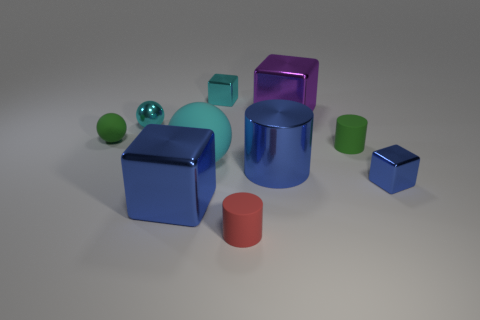Subtract all blue blocks. How many were subtracted if there are1blue blocks left? 1 Subtract all cubes. How many objects are left? 6 Add 2 tiny shiny balls. How many tiny shiny balls are left? 3 Add 4 small brown matte cubes. How many small brown matte cubes exist? 4 Subtract 1 blue cylinders. How many objects are left? 9 Subtract all cyan blocks. Subtract all cylinders. How many objects are left? 6 